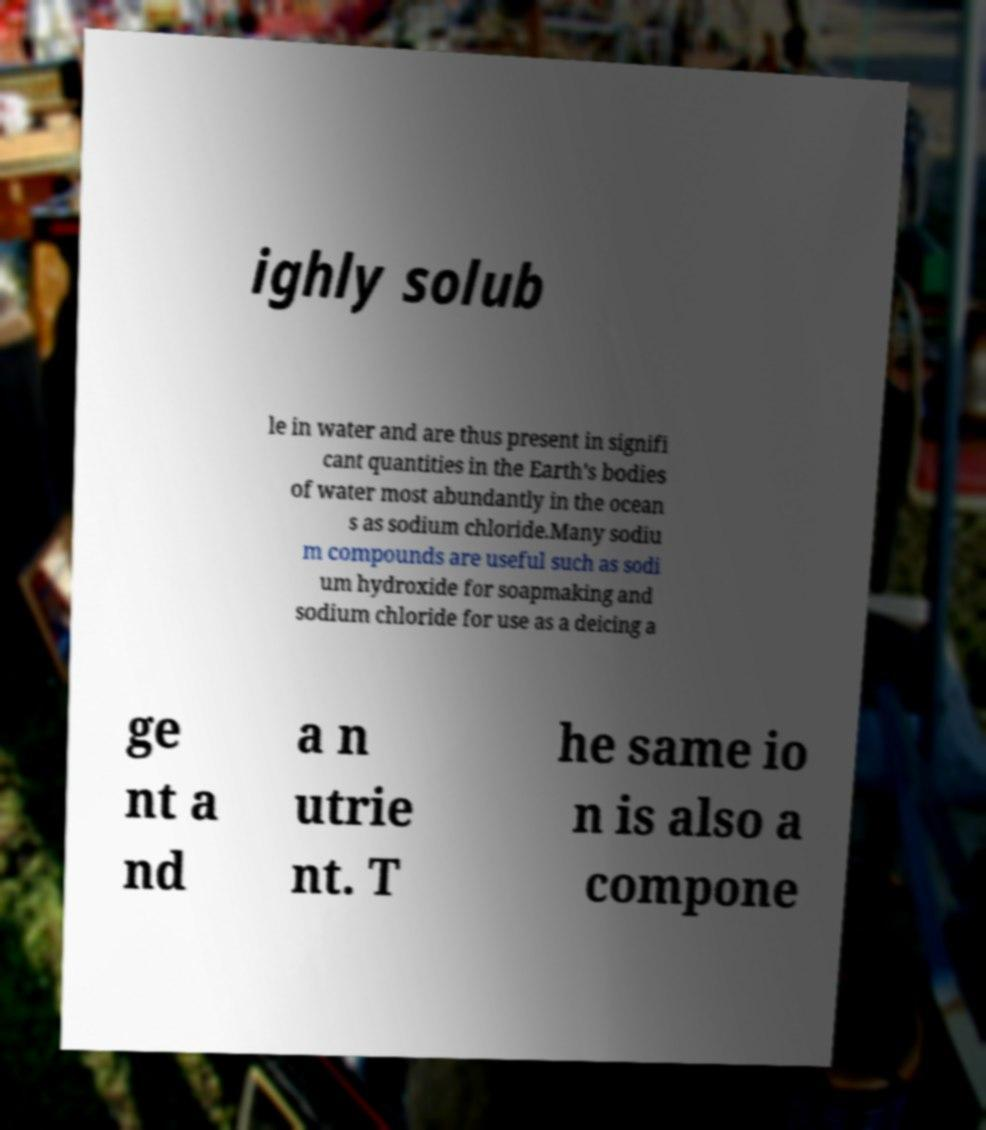There's text embedded in this image that I need extracted. Can you transcribe it verbatim? ighly solub le in water and are thus present in signifi cant quantities in the Earth's bodies of water most abundantly in the ocean s as sodium chloride.Many sodiu m compounds are useful such as sodi um hydroxide for soapmaking and sodium chloride for use as a deicing a ge nt a nd a n utrie nt. T he same io n is also a compone 